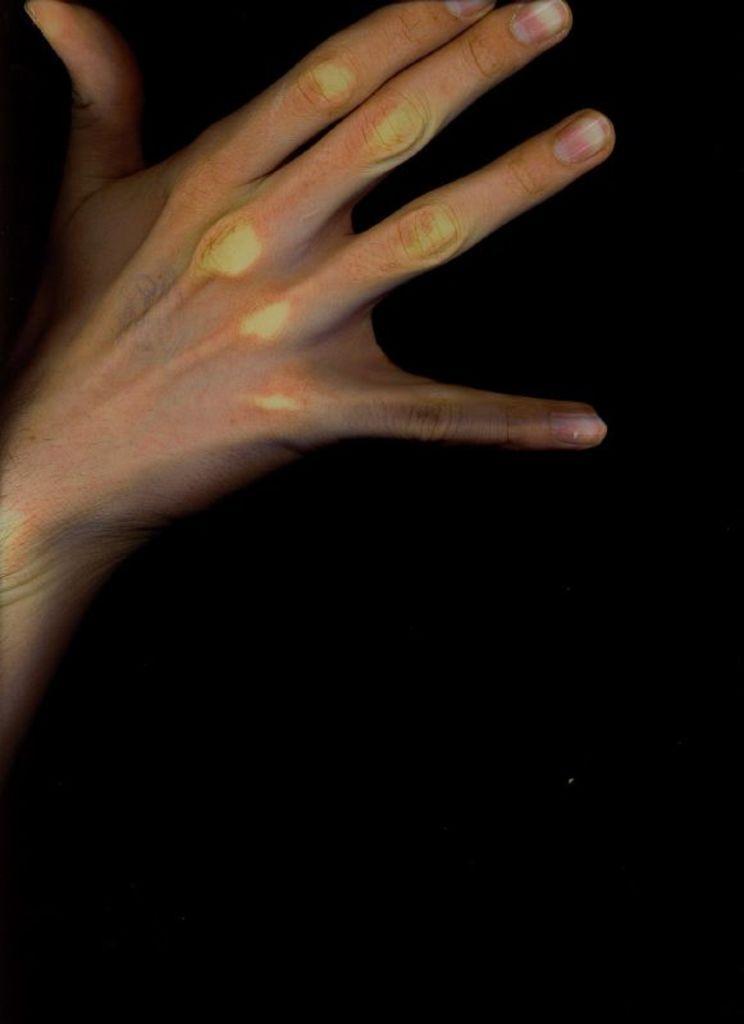How would you summarize this image in a sentence or two? In this picture we can see a person's hand. Behind the hand, there is the dark background. 